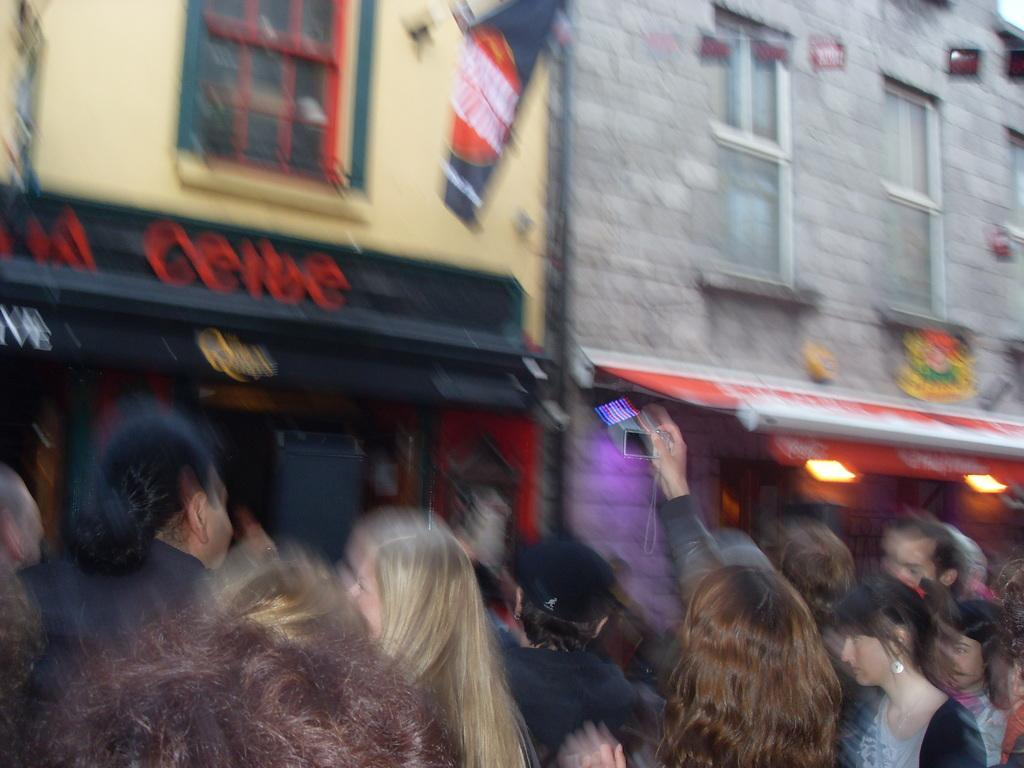What can be seen on the streets in the image? There are people on the streets in the image. What type of structures are visible in the image? There are buildings in the image. What kind of illumination is present in the image? There are lights in the image. What architectural features can be seen on the buildings? There are windows in the image. What symbol or emblem is present in the image? There is a flag in the image. What type of orange is being sold at the beef stand in the image? There is no orange or beef stand present in the image. How much is the payment for the services provided in the image? There is no payment or service being exchanged in the image. 